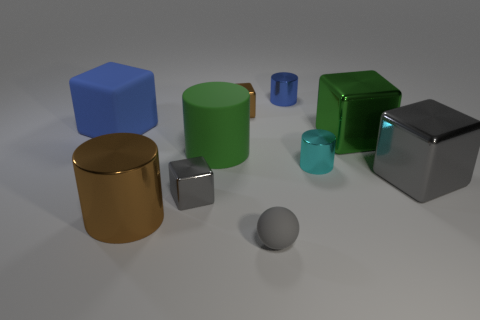Does the matte cylinder have the same color as the metallic object that is on the right side of the large green metal block?
Your answer should be very brief. No. Are there any matte cylinders of the same size as the cyan shiny object?
Make the answer very short. No. The gray cube in front of the gray cube that is to the right of the tiny gray metallic object is made of what material?
Your answer should be very brief. Metal. What number of tiny blocks are the same color as the large matte cylinder?
Offer a terse response. 0. There is a blue object that is the same material as the small gray sphere; what is its shape?
Offer a very short reply. Cube. There is a matte object in front of the big brown thing; what is its size?
Ensure brevity in your answer.  Small. Is the number of small brown blocks in front of the large green metallic object the same as the number of tiny blue cylinders that are on the left side of the tiny sphere?
Your answer should be very brief. Yes. There is a matte object that is in front of the large shiny thing that is to the left of the gray thing that is in front of the large brown cylinder; what color is it?
Your answer should be compact. Gray. How many things are behind the cyan metallic cylinder and to the right of the tiny blue shiny thing?
Your answer should be compact. 1. There is a tiny cube behind the rubber cube; does it have the same color as the big block that is left of the small ball?
Your response must be concise. No. 